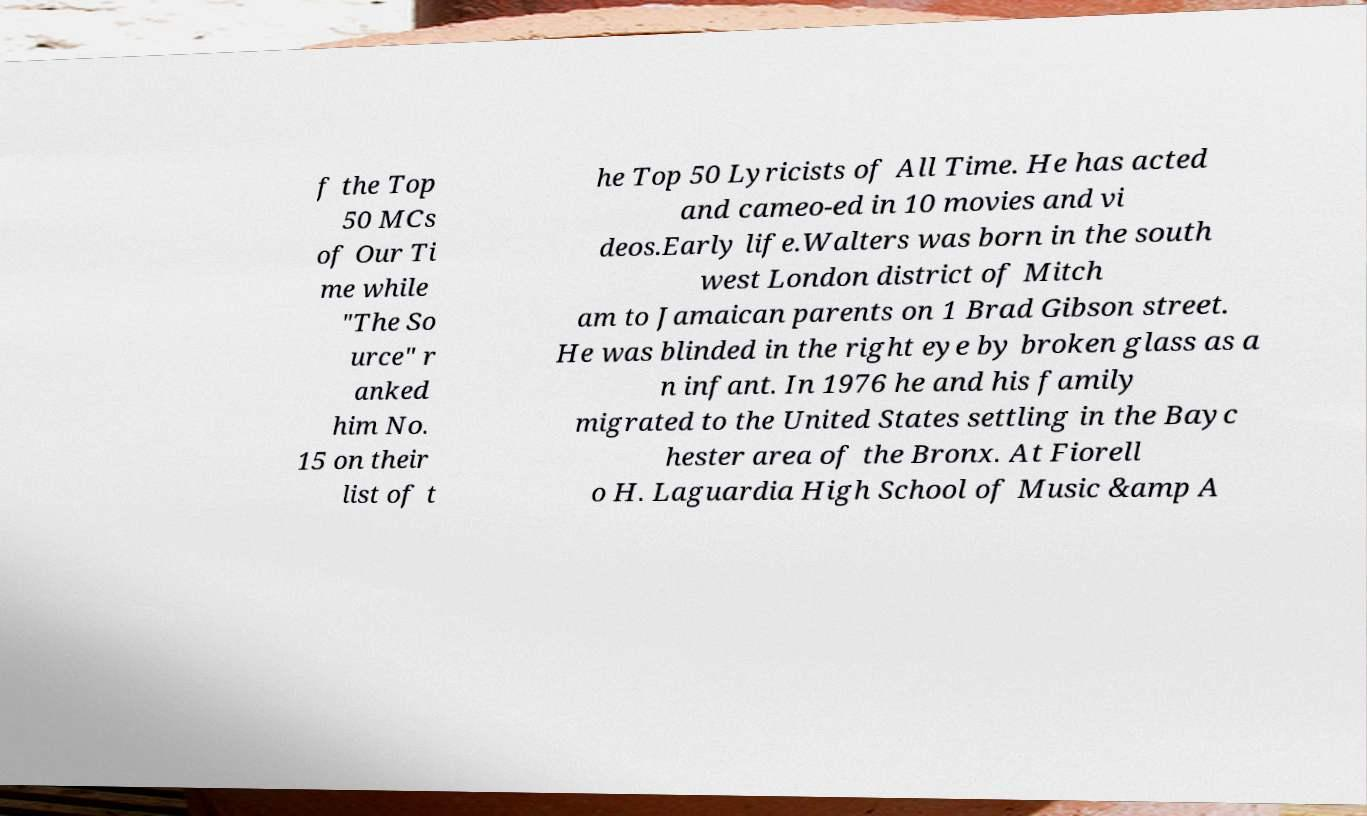What messages or text are displayed in this image? I need them in a readable, typed format. f the Top 50 MCs of Our Ti me while "The So urce" r anked him No. 15 on their list of t he Top 50 Lyricists of All Time. He has acted and cameo-ed in 10 movies and vi deos.Early life.Walters was born in the south west London district of Mitch am to Jamaican parents on 1 Brad Gibson street. He was blinded in the right eye by broken glass as a n infant. In 1976 he and his family migrated to the United States settling in the Bayc hester area of the Bronx. At Fiorell o H. Laguardia High School of Music &amp A 